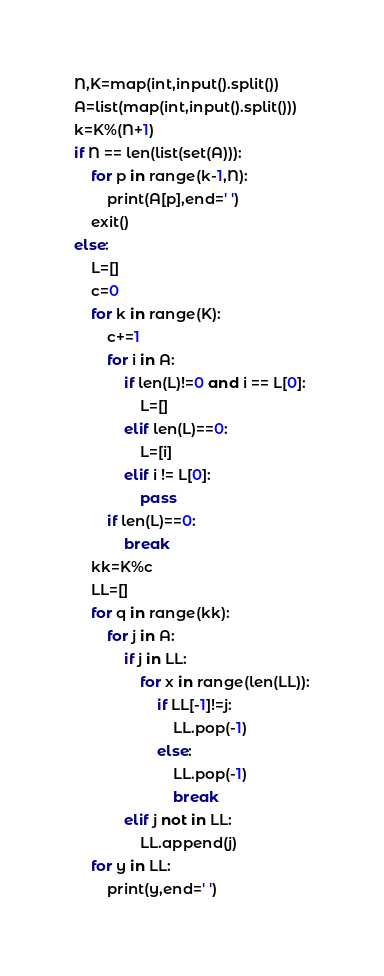Convert code to text. <code><loc_0><loc_0><loc_500><loc_500><_Python_>N,K=map(int,input().split())
A=list(map(int,input().split()))
k=K%(N+1)
if N == len(list(set(A))):
    for p in range(k-1,N):
        print(A[p],end=' ')
    exit()
else:
    L=[]
    c=0
    for k in range(K):
        c+=1
        for i in A:
            if len(L)!=0 and i == L[0]:
                L=[]
            elif len(L)==0:
                L=[i]
            elif i != L[0]:
                pass
        if len(L)==0:
            break
    kk=K%c
    LL=[]
    for q in range(kk):
        for j in A:
            if j in LL:
                for x in range(len(LL)):
                    if LL[-1]!=j:
                        LL.pop(-1)
                    else:
                        LL.pop(-1)
                        break
            elif j not in LL:
                LL.append(j)
    for y in LL:
        print(y,end=' ')</code> 